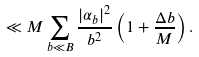<formula> <loc_0><loc_0><loc_500><loc_500>\ll M \sum _ { b \ll B } \frac { | \alpha _ { b } | ^ { 2 } } { b ^ { 2 } } \left ( 1 + \frac { \Delta b } { M } \right ) .</formula> 